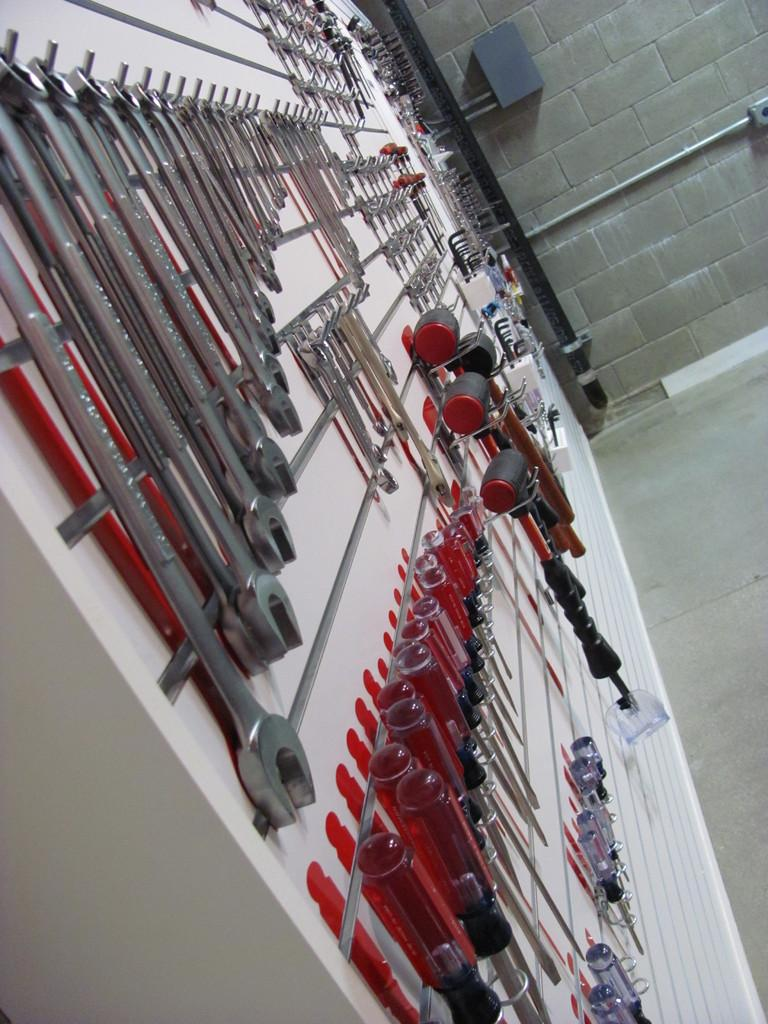What is hanging on the white wall in the image? There are tools and pipes on the wall in the image. Can you describe the ground visible in the image? The ground is visible in the image, but no specific details are provided about its appearance. What is the color of the wall in the image? The wall in the image is white. Can you tell me how many kittens are sitting on the pipes in the image? There are no kittens present in the image; it features tools and pipes on a white wall. What type of monkey can be seen climbing the tools in the image? There are no monkeys present in the image; it features tools and pipes on a white wall. 